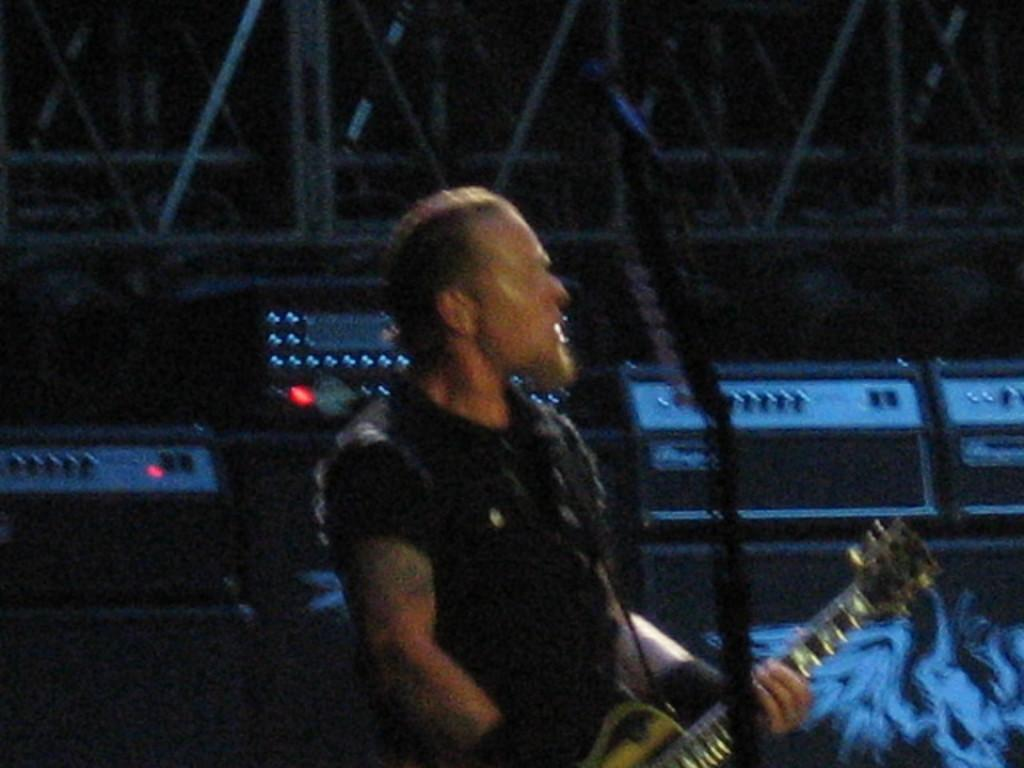What is the main subject of the image? There is a person in the image. What is the person holding in the image? The person is holding a guitar. What type of anger can be seen on the person's face in the image? There is no indication of anger on the person's face in the image. What type of appliance is the person using to play the guitar in the image? There is no appliance present in the image; the person is simply holding a guitar. Can you see any twigs in the image? There is no mention of twigs in the image; it features a person holding a guitar. 